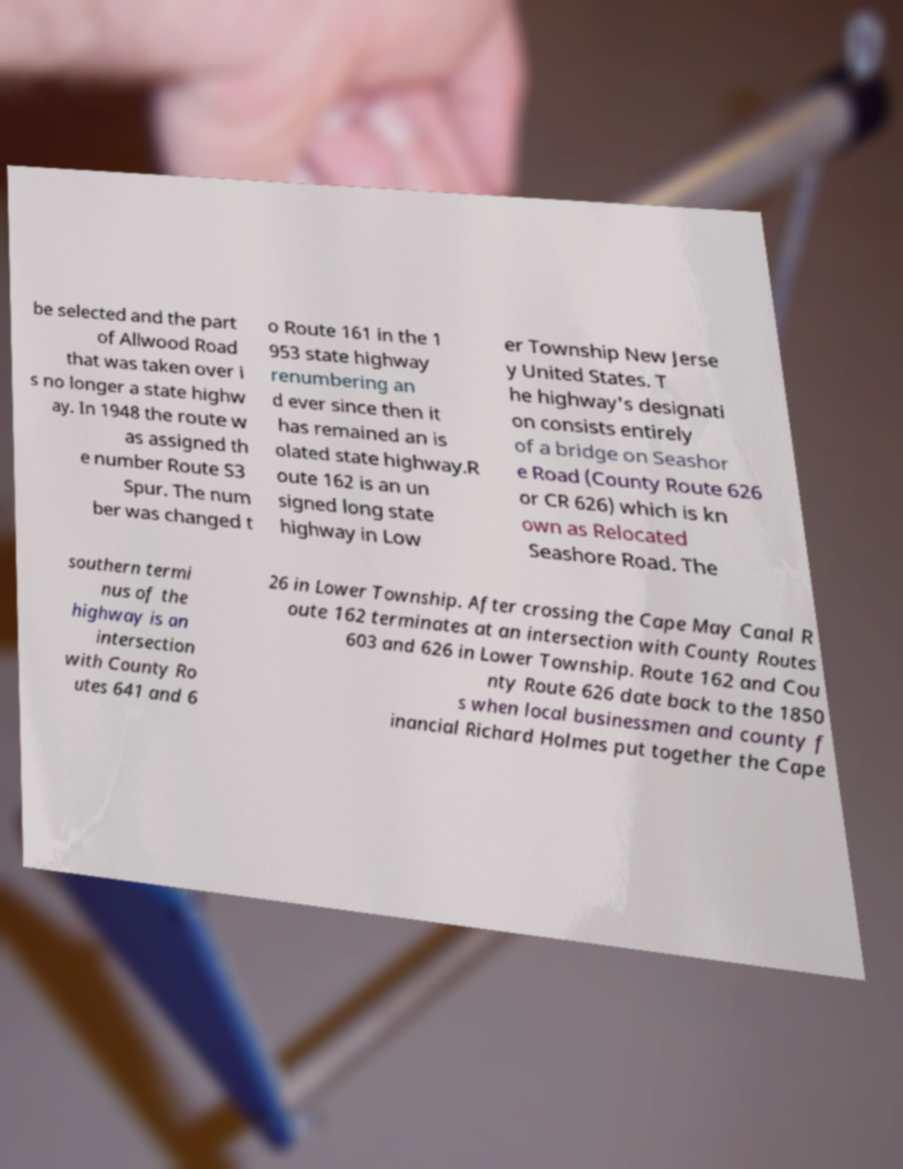For documentation purposes, I need the text within this image transcribed. Could you provide that? be selected and the part of Allwood Road that was taken over i s no longer a state highw ay. In 1948 the route w as assigned th e number Route S3 Spur. The num ber was changed t o Route 161 in the 1 953 state highway renumbering an d ever since then it has remained an is olated state highway.R oute 162 is an un signed long state highway in Low er Township New Jerse y United States. T he highway's designati on consists entirely of a bridge on Seashor e Road (County Route 626 or CR 626) which is kn own as Relocated Seashore Road. The southern termi nus of the highway is an intersection with County Ro utes 641 and 6 26 in Lower Township. After crossing the Cape May Canal R oute 162 terminates at an intersection with County Routes 603 and 626 in Lower Township. Route 162 and Cou nty Route 626 date back to the 1850 s when local businessmen and county f inancial Richard Holmes put together the Cape 